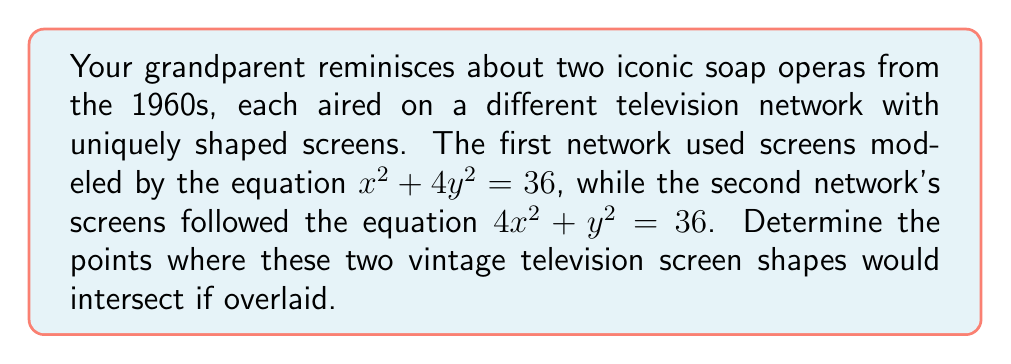Can you solve this math problem? Let's approach this step-by-step:

1) We have two equations representing conic sections (ellipses in this case):
   Equation 1: $x^2 + 4y^2 = 36$
   Equation 2: $4x^2 + y^2 = 36$

2) To find the intersection points, we need to solve these equations simultaneously.

3) Let's rearrange Equation 1 to isolate $y^2$:
   $4y^2 = 36 - x^2$
   $y^2 = 9 - \frac{1}{4}x^2$

4) Now, substitute this expression for $y^2$ into Equation 2:
   $4x^2 + (9 - \frac{1}{4}x^2) = 36$

5) Simplify:
   $4x^2 + 9 - \frac{1}{4}x^2 = 36$
   $\frac{15}{4}x^2 = 27$
   $x^2 = \frac{72}{15} = \frac{24}{5}$

6) Solve for x:
   $x = \pm \sqrt{\frac{24}{5}} = \pm \frac{2\sqrt{6}}{\sqrt{5}}$

7) Substitute these x-values back into Equation 1 to find y:
   $(\frac{2\sqrt{6}}{\sqrt{5}})^2 + 4y^2 = 36$
   $\frac{24}{5} + 4y^2 = 36$
   $4y^2 = 36 - \frac{24}{5} = \frac{156}{5}$
   $y^2 = \frac{39}{5}$
   $y = \pm \frac{\sqrt{39}}{\sqrt{5}}$

8) Therefore, the intersection points are:
   $(\frac{2\sqrt{6}}{\sqrt{5}}, \frac{\sqrt{39}}{\sqrt{5}})$ and $(-\frac{2\sqrt{6}}{\sqrt{5}}, -\frac{\sqrt{39}}{\sqrt{5}})$
Answer: $(\pm\frac{2\sqrt{6}}{\sqrt{5}}, \pm\frac{\sqrt{39}}{\sqrt{5}})$ 